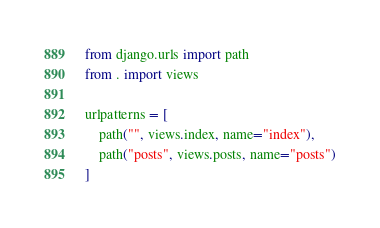Convert code to text. <code><loc_0><loc_0><loc_500><loc_500><_Python_>from django.urls import path
from . import views

urlpatterns = [
    path("", views.index, name="index"),
    path("posts", views.posts, name="posts")
]
</code> 